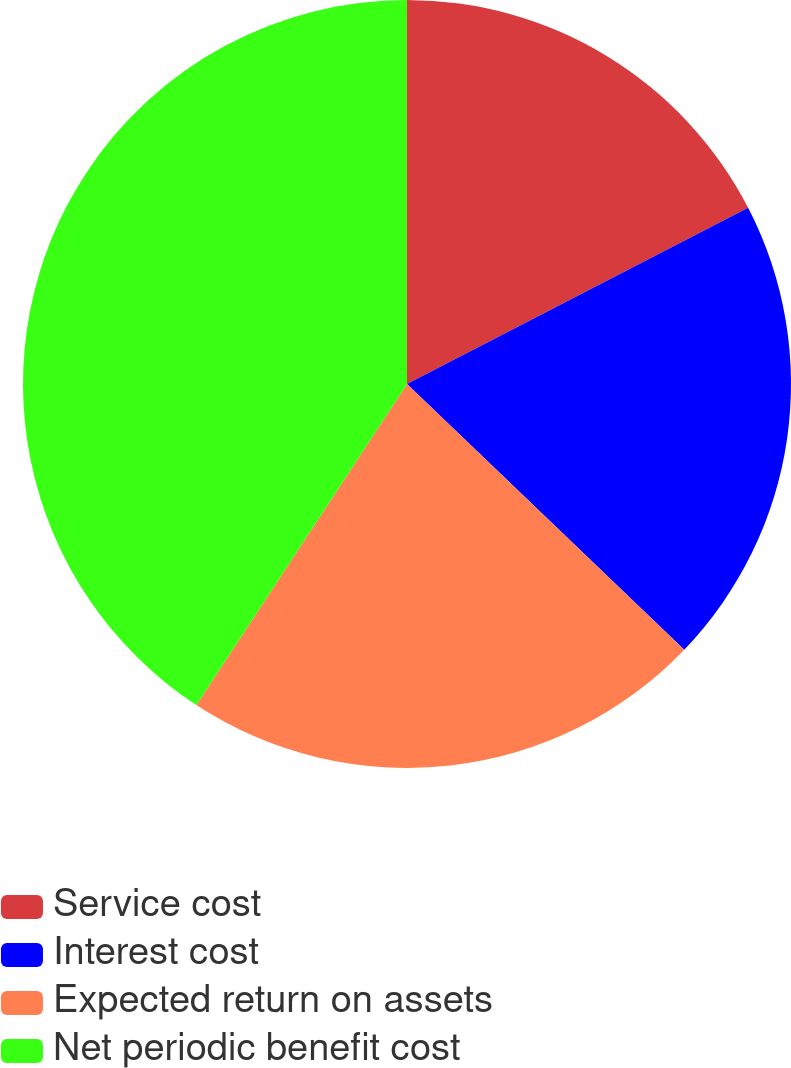Convert chart to OTSL. <chart><loc_0><loc_0><loc_500><loc_500><pie_chart><fcel>Service cost<fcel>Interest cost<fcel>Expected return on assets<fcel>Net periodic benefit cost<nl><fcel>17.41%<fcel>19.75%<fcel>22.08%<fcel>40.76%<nl></chart> 